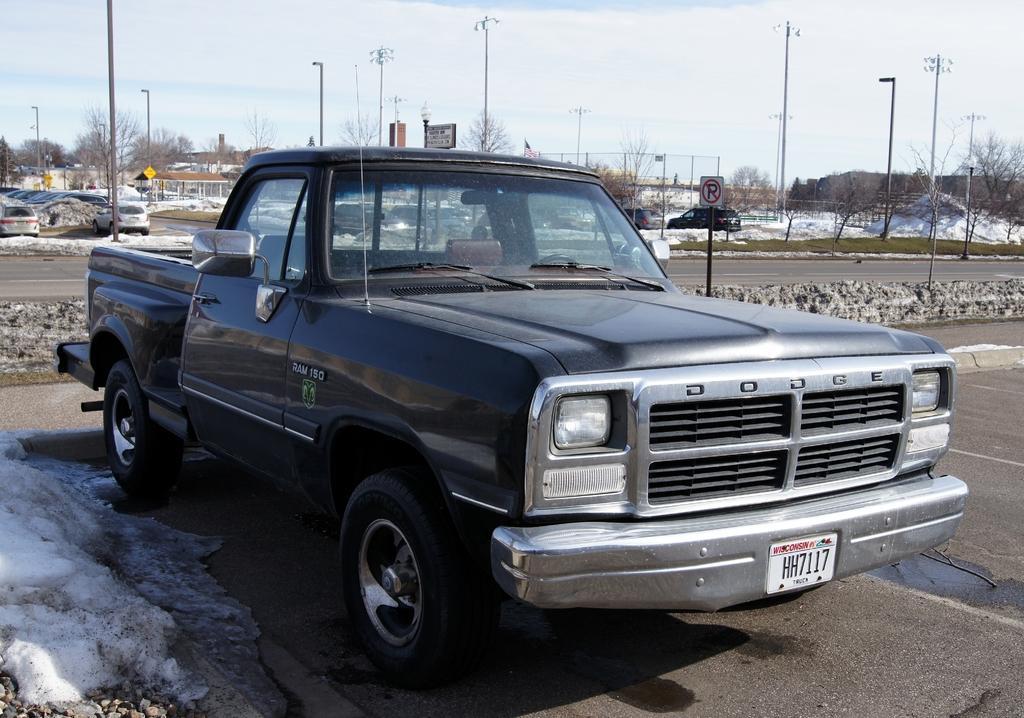Describe this image in one or two sentences. In front of the picture, we see the black car is parked on the road. Behind that, we see the poles and street lights. In the background, we see the poles, street lights, cars, buildings and trees. At the top, we see the sky. 